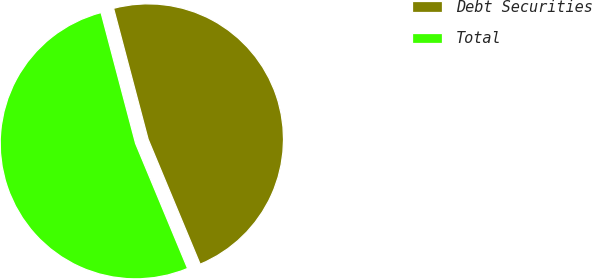Convert chart to OTSL. <chart><loc_0><loc_0><loc_500><loc_500><pie_chart><fcel>Debt Securities<fcel>Total<nl><fcel>47.83%<fcel>52.17%<nl></chart> 